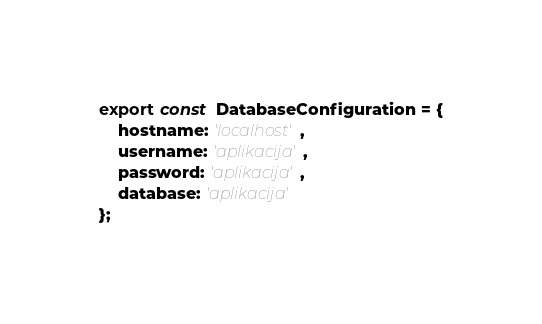Convert code to text. <code><loc_0><loc_0><loc_500><loc_500><_TypeScript_>export const  DatabaseConfiguration = {
    hostname: 'localhost',
    username: 'aplikacija',
    password: 'aplikacija',
    database: 'aplikacija'
};</code> 